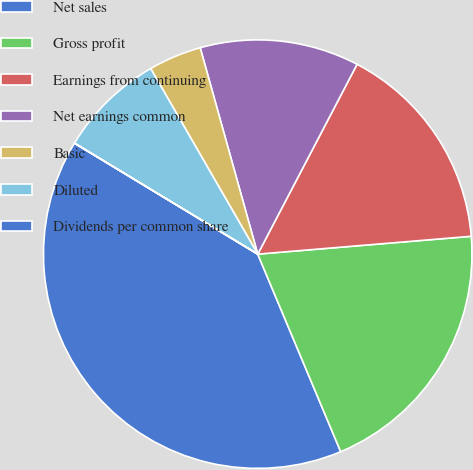Convert chart. <chart><loc_0><loc_0><loc_500><loc_500><pie_chart><fcel>Net sales<fcel>Gross profit<fcel>Earnings from continuing<fcel>Net earnings common<fcel>Basic<fcel>Diluted<fcel>Dividends per common share<nl><fcel>39.99%<fcel>20.0%<fcel>16.0%<fcel>12.0%<fcel>4.0%<fcel>8.0%<fcel>0.01%<nl></chart> 